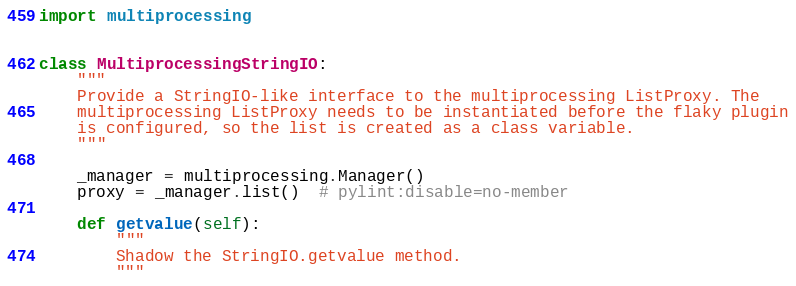Convert code to text. <code><loc_0><loc_0><loc_500><loc_500><_Python_>import multiprocessing


class MultiprocessingStringIO:
    """
    Provide a StringIO-like interface to the multiprocessing ListProxy. The
    multiprocessing ListProxy needs to be instantiated before the flaky plugin
    is configured, so the list is created as a class variable.
    """

    _manager = multiprocessing.Manager()
    proxy = _manager.list()  # pylint:disable=no-member

    def getvalue(self):
        """
        Shadow the StringIO.getvalue method.
        """</code> 